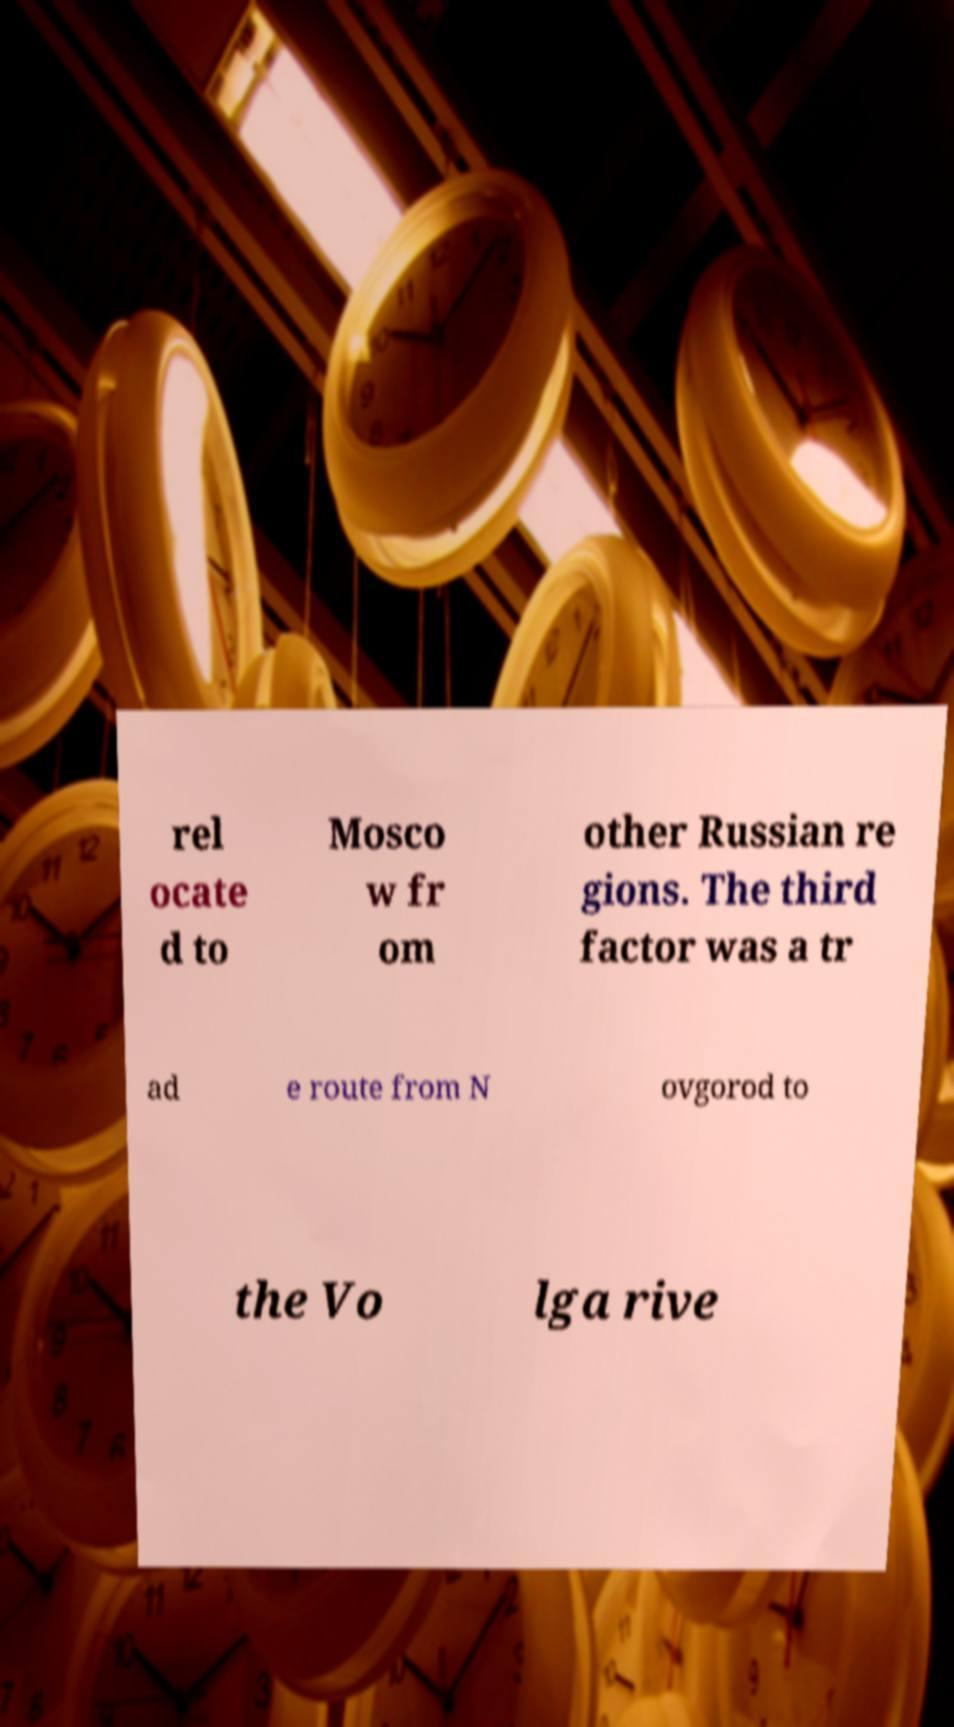Could you assist in decoding the text presented in this image and type it out clearly? rel ocate d to Mosco w fr om other Russian re gions. The third factor was a tr ad e route from N ovgorod to the Vo lga rive 